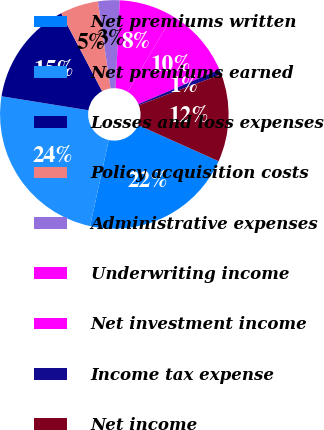Convert chart. <chart><loc_0><loc_0><loc_500><loc_500><pie_chart><fcel>Net premiums written<fcel>Net premiums earned<fcel>Losses and loss expenses<fcel>Policy acquisition costs<fcel>Administrative expenses<fcel>Underwriting income<fcel>Net investment income<fcel>Income tax expense<fcel>Net income<nl><fcel>21.69%<fcel>24.14%<fcel>14.77%<fcel>5.4%<fcel>3.05%<fcel>7.74%<fcel>10.08%<fcel>0.71%<fcel>12.42%<nl></chart> 